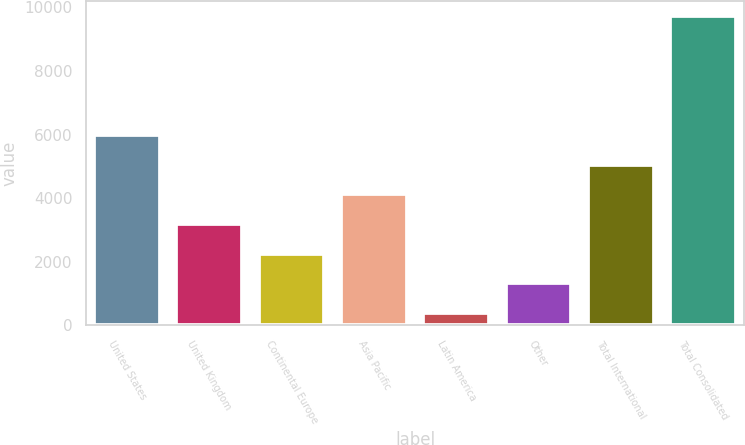Convert chart. <chart><loc_0><loc_0><loc_500><loc_500><bar_chart><fcel>United States<fcel>United Kingdom<fcel>Continental Europe<fcel>Asia Pacific<fcel>Latin America<fcel>Other<fcel>Total International<fcel>Total Consolidated<nl><fcel>5984.24<fcel>3186.62<fcel>2254.08<fcel>4119.16<fcel>389<fcel>1321.54<fcel>5051.7<fcel>9714.4<nl></chart> 